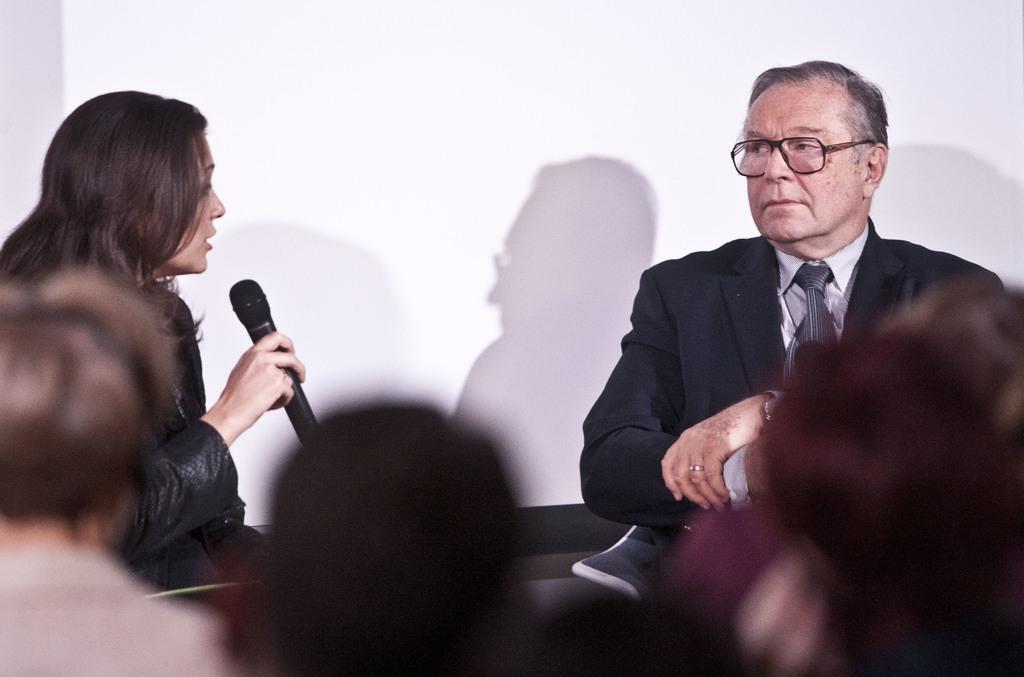How would you summarize this image in a sentence or two? In this picture there are some people sitting and opposite to them there are two people one among them is a man wearing black suit and the other is a lady holding a mic. 